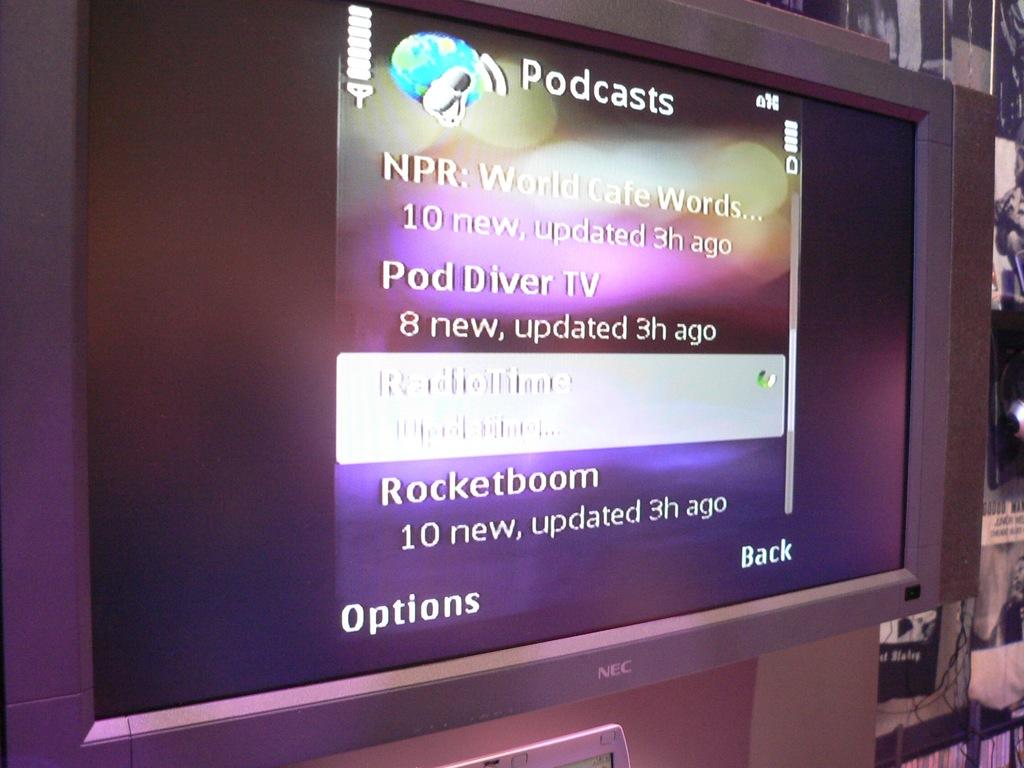How many hours ago were the podcasts updated?
Your response must be concise. 3. What is this about?
Your answer should be very brief. Podcasts. 